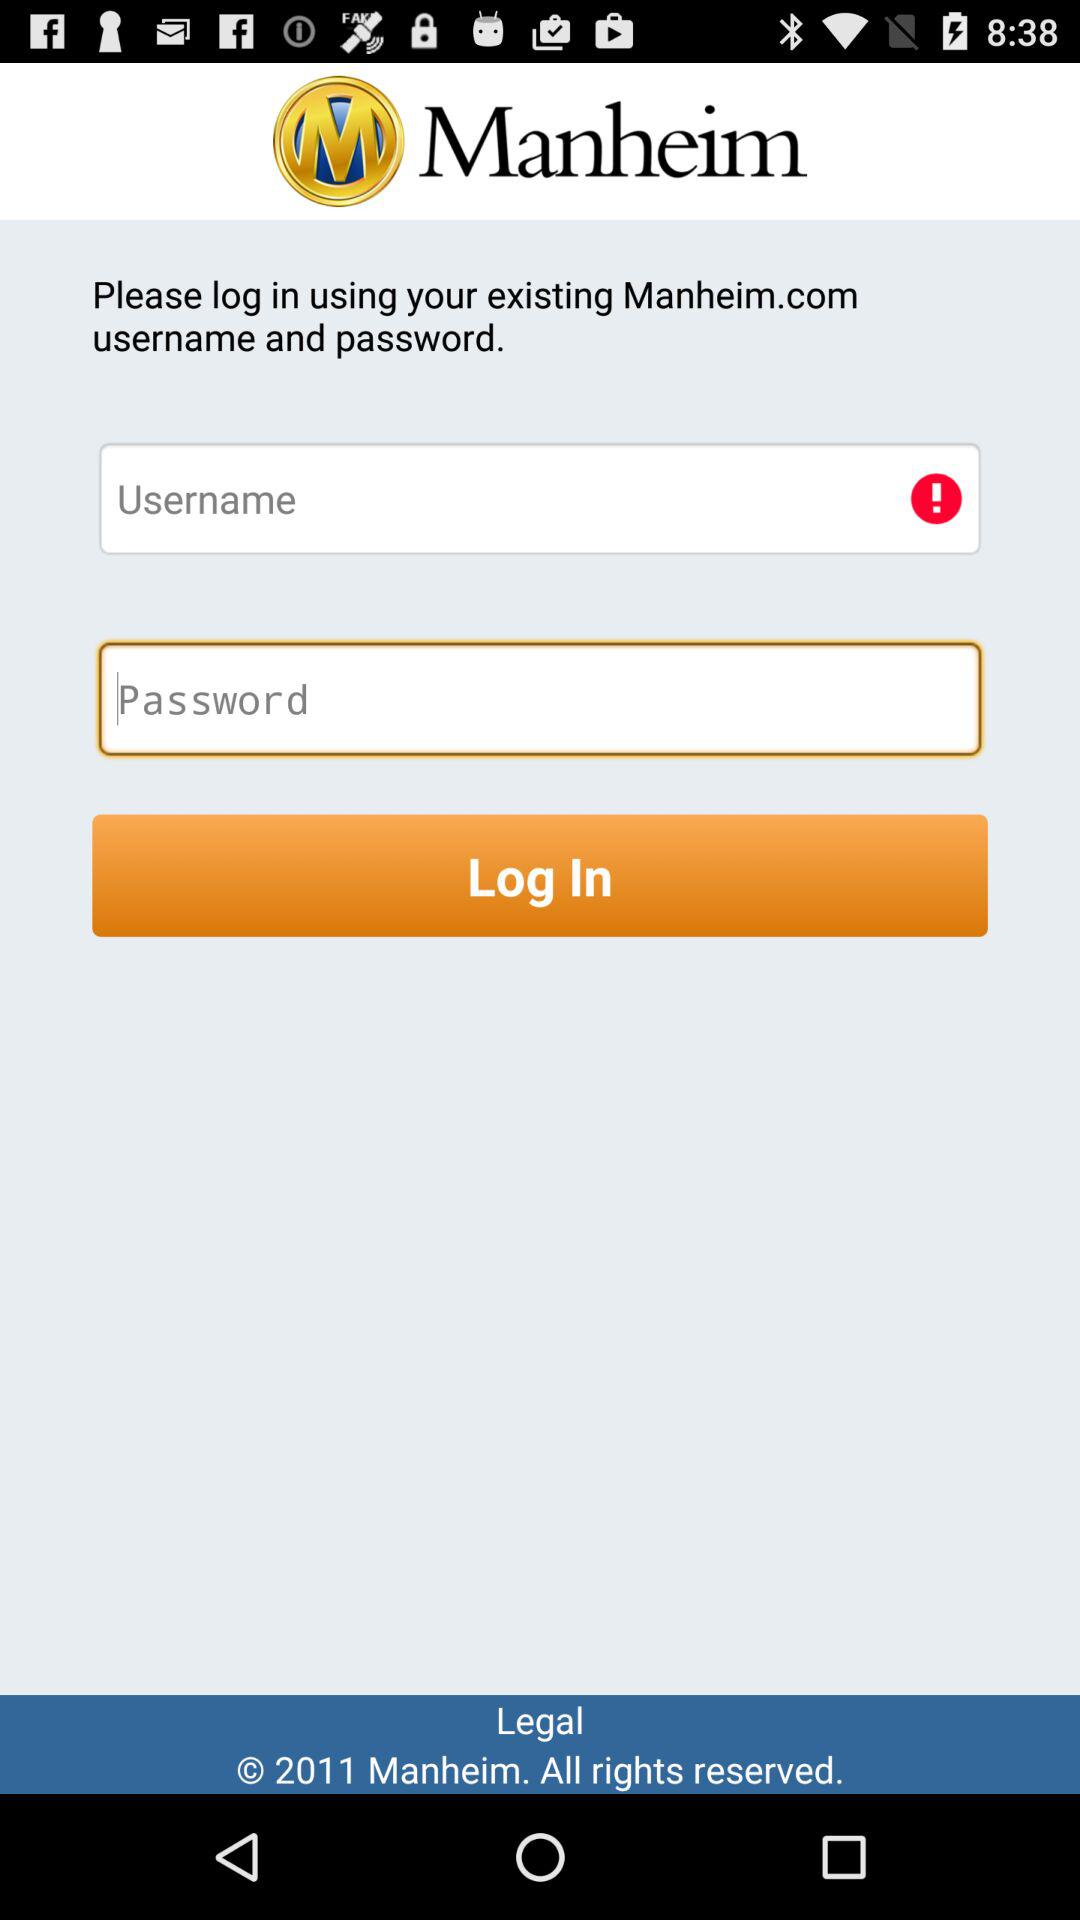What is the name of the application? The name of the application is "Manheim". 